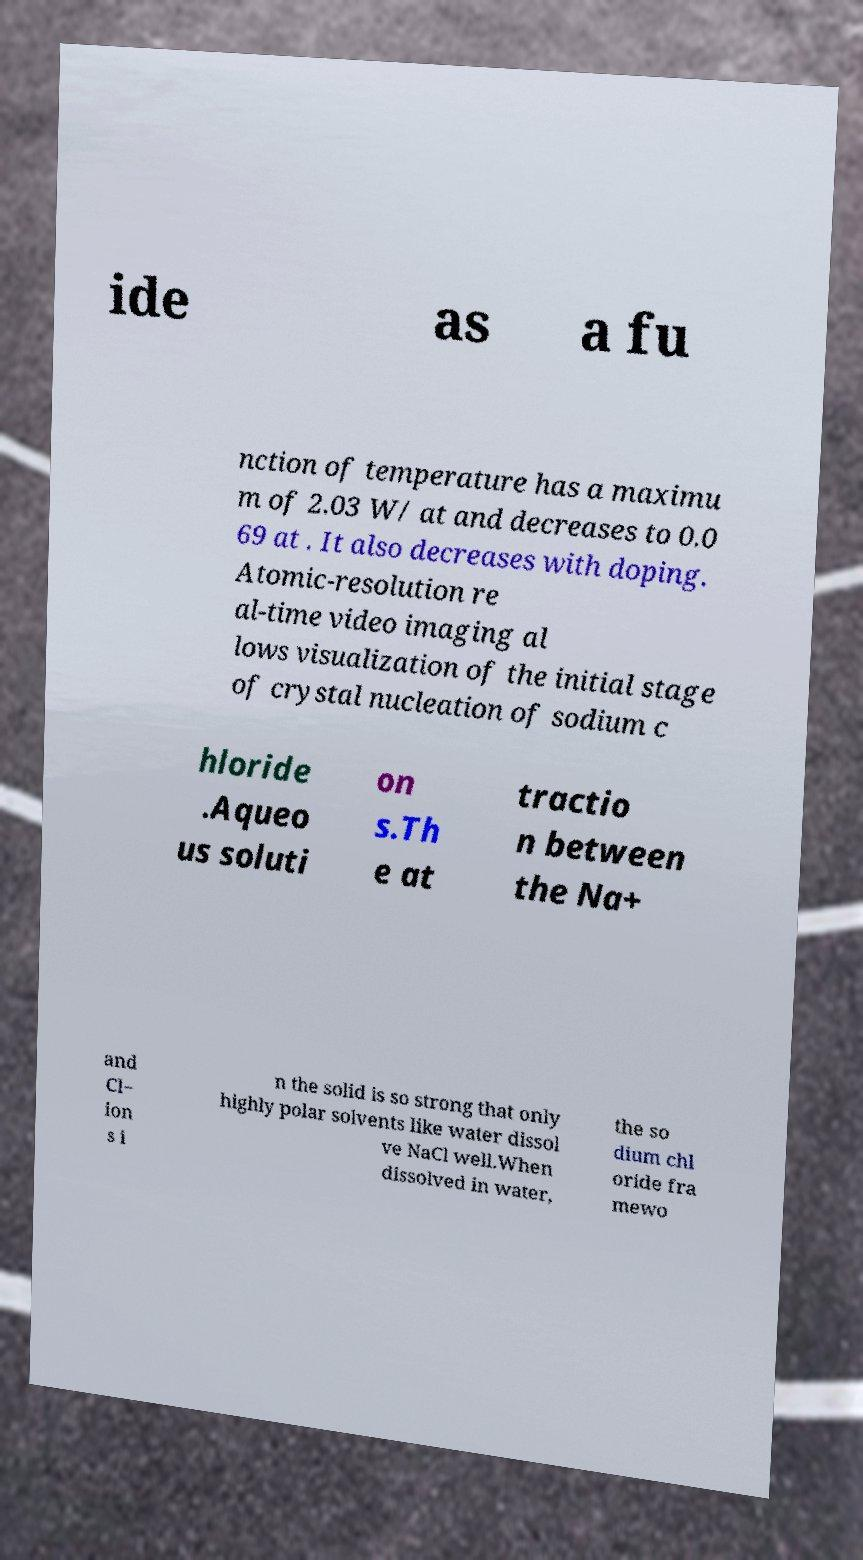There's text embedded in this image that I need extracted. Can you transcribe it verbatim? ide as a fu nction of temperature has a maximu m of 2.03 W/ at and decreases to 0.0 69 at . It also decreases with doping. Atomic-resolution re al-time video imaging al lows visualization of the initial stage of crystal nucleation of sodium c hloride .Aqueo us soluti on s.Th e at tractio n between the Na+ and Cl− ion s i n the solid is so strong that only highly polar solvents like water dissol ve NaCl well.When dissolved in water, the so dium chl oride fra mewo 